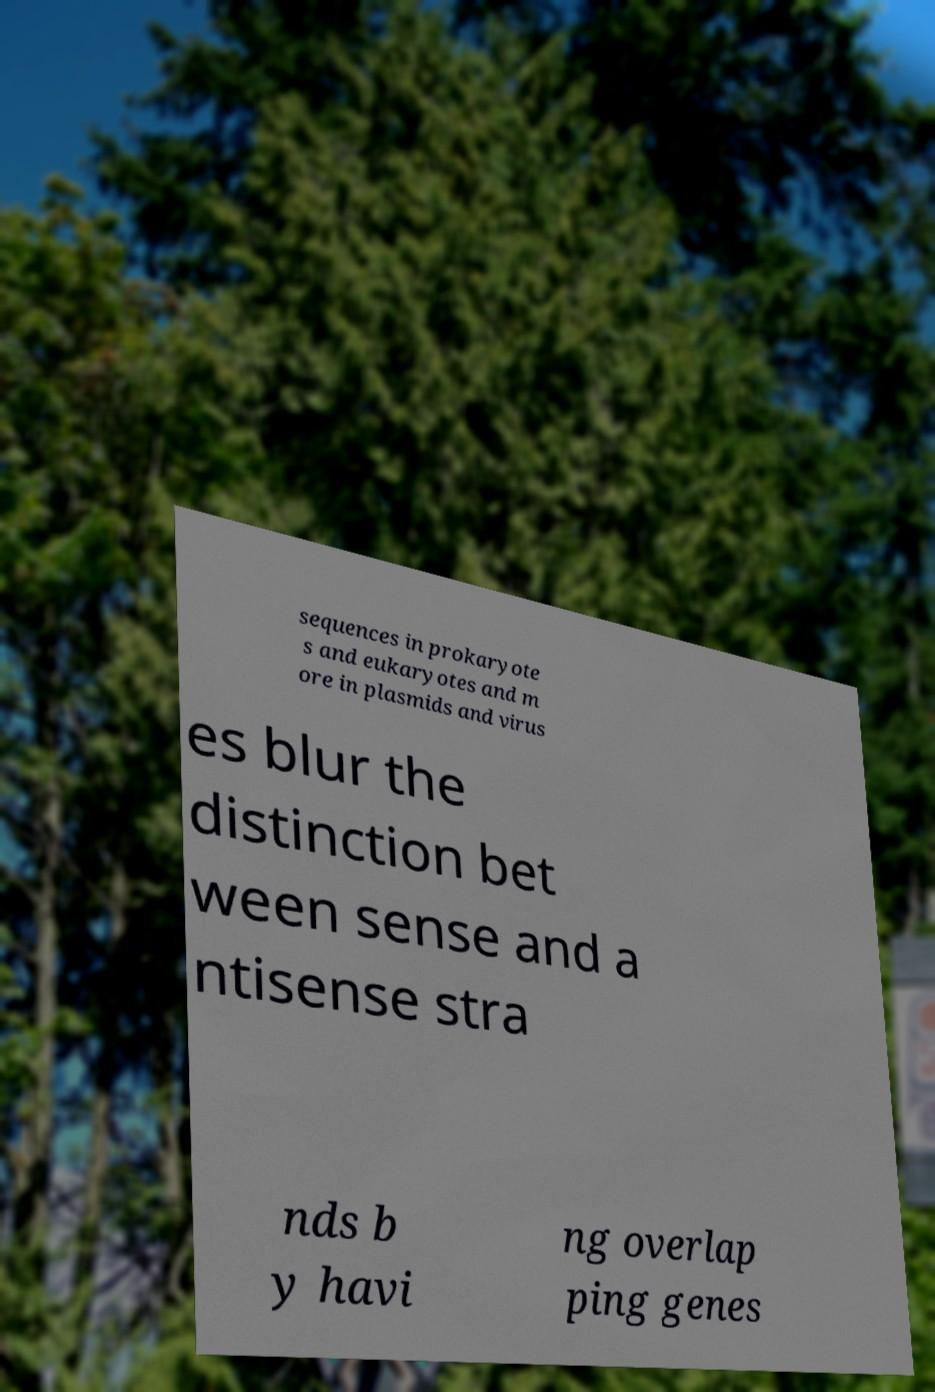For documentation purposes, I need the text within this image transcribed. Could you provide that? sequences in prokaryote s and eukaryotes and m ore in plasmids and virus es blur the distinction bet ween sense and a ntisense stra nds b y havi ng overlap ping genes 